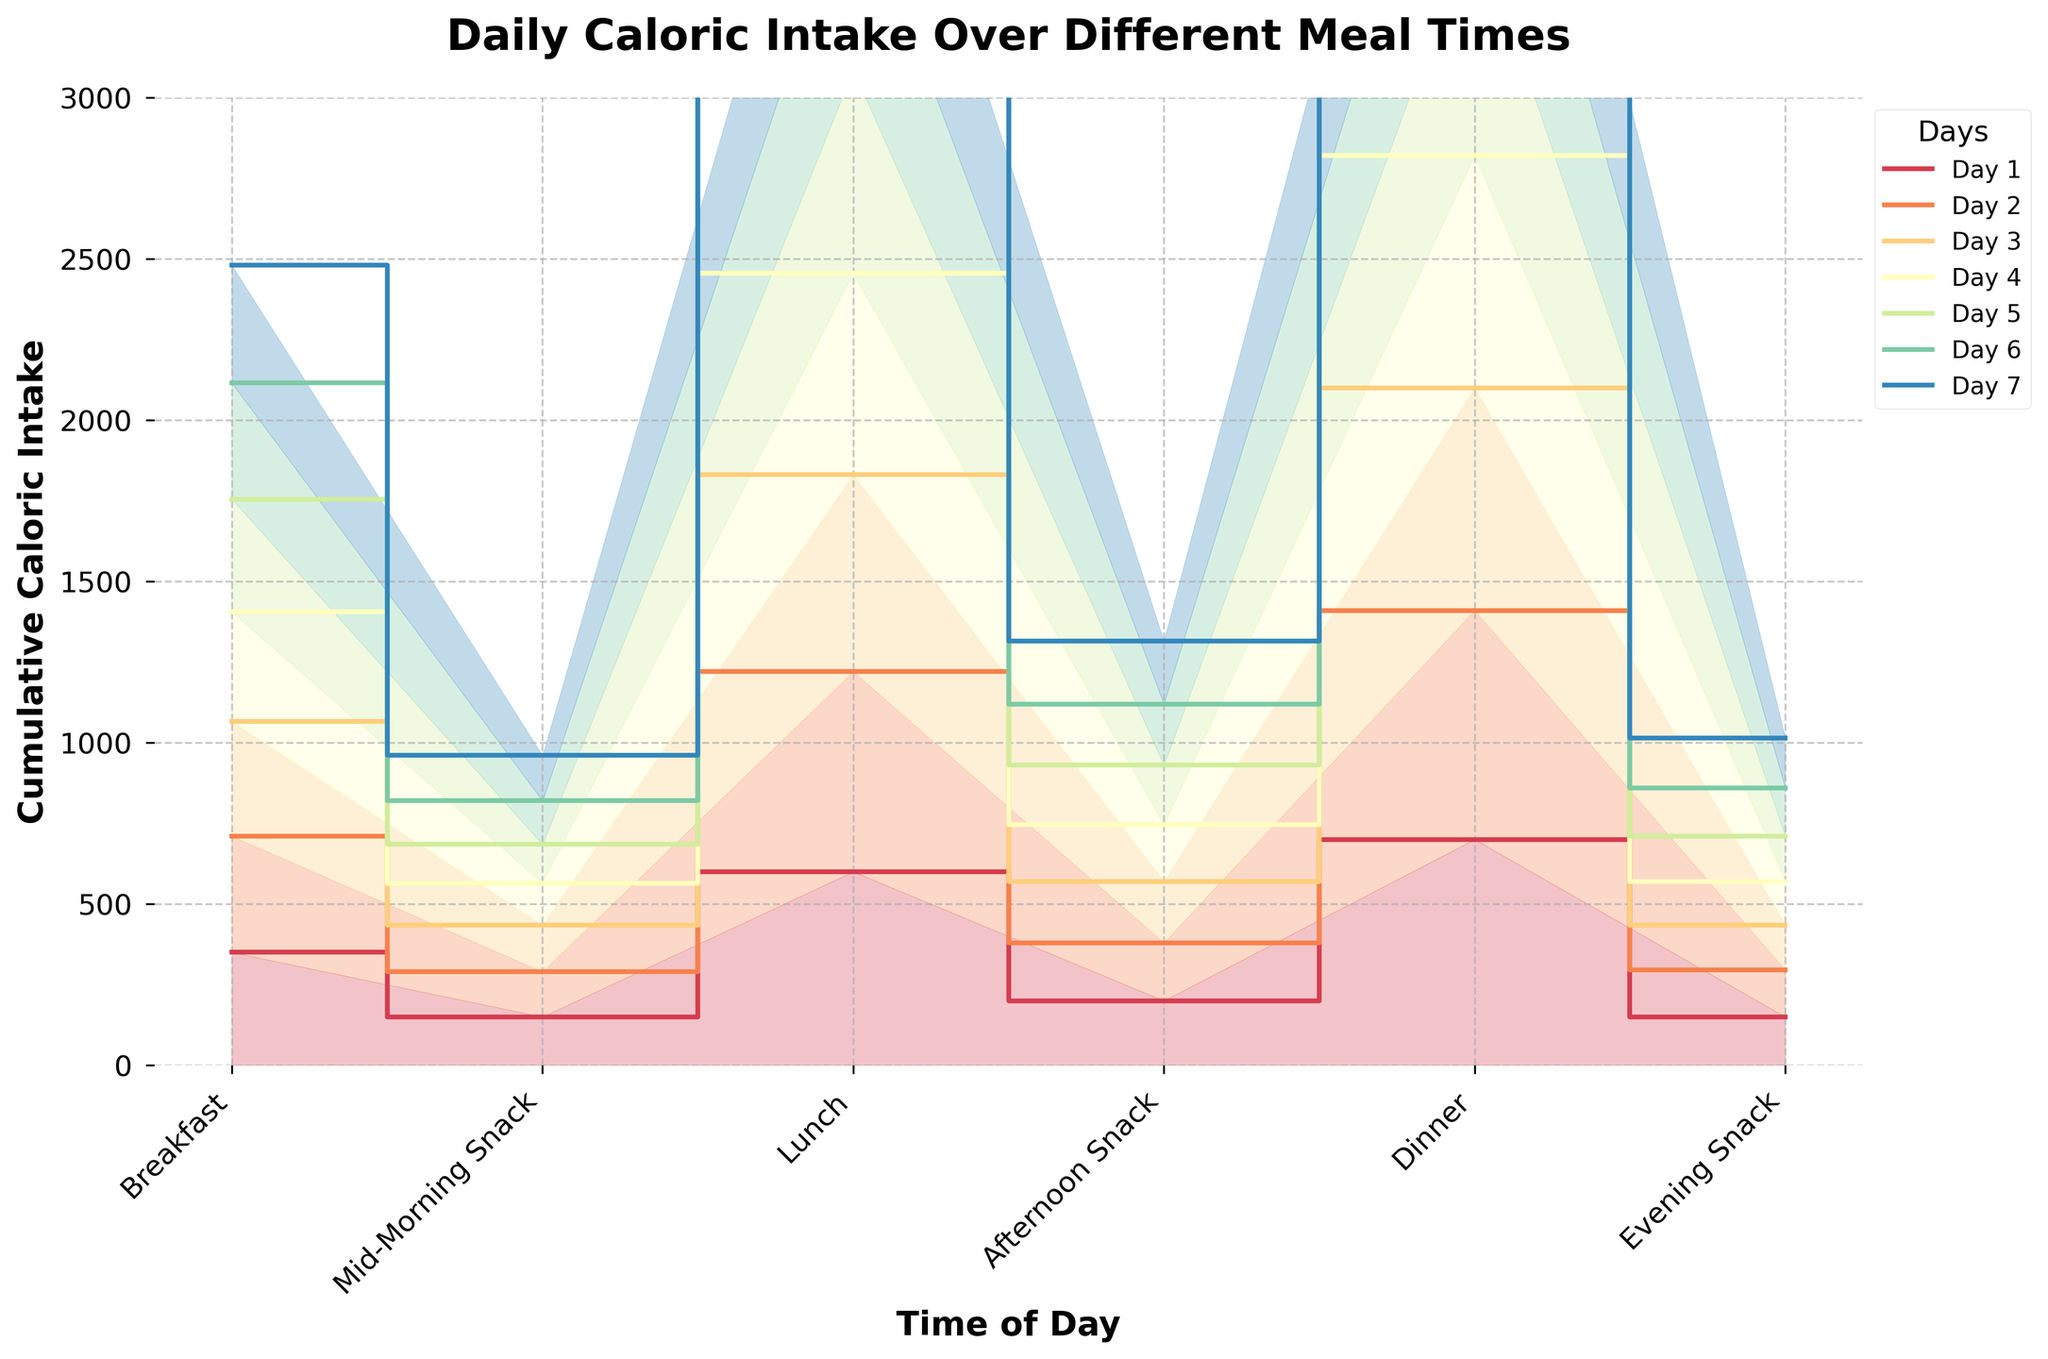How many meal times are plotted on the chart? The chart plots caloric intake over different meal times. By examining the x-axis, there are six meal times listed: Breakfast, Mid-Morning Snack, Lunch, Afternoon Snack, Dinner, and Evening Snack.
Answer: Six Which day had the highest caloric intake for Lunch? To determine which day had the highest caloric intake for Lunch, look at the step heights for Lunch. It is clear that Day 5 had the highest value at 630 calories.
Answer: Day 5 Between which two meal times does the largest increase in caloric intake occur? We need to compare the differences in caloric intake between successive meal times for the day with the largest cumulative intake. The largest increase is between Lunch and Dinner, with notable accumulations from the lunch values around 600-630 calories to dinner values around 690-730 calories.
Answer: Lunch to Dinner Which day has the steepest increase in caloric intake between Breakfast and Mid-Morning Snack? By observing the steps between Breakfast and Mid-Morning Snack, we can see that there is a steep drop for Day 5, from 350 to 120 calories.
Answer: Day 5 What is the total caloric intake for Day 3? The total caloric intake for Day 3 is the sum of calories for each meal time: 355 (Breakfast) + 145 (Mid-Morning Snack) + 610 (Lunch) + 190 (Afternoon Snack) + 690 (Dinner) + 140 (Evening Snack) = 2130 calories.
Answer: 2130 Which meal time consistently has the lowest caloric intake across all days? By examining the step sizes and filled areas, Mid-Morning Snack consistently has the lowest caloric intake each day, ranging between 120 to 150 calories.
Answer: Mid-Morning Snack How does the caloric intake for Day 1's Afternoon Snack compare to Day 6's? By inspecting the vertical step sizes, Day 1's Afternoon Snack caloric intake is 200 calories, whereas for Day 6 it is 190 calories. Thus, Day 1 has a higher intake for this meal time.
Answer: Day 1 is higher What is the average caloric intake for Dinner over all days? To find the average caloric intake for Dinner, we sum up the intake for all days: 700 + 710 + 690 + 720 + 730 + 695 + 705 = 4950, and then divide by 7 days. The average is 4950/7 = 707.14 calories.
Answer: 707.14 Which day had the lowest cumulative caloric intake? Observing the highest points of the cumulative steps, Day 3 reaches the lowest cumulative caloric intake when compared to other days, ending around 2130 calories.
Answer: Day 3 